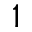Convert formula to latex. <formula><loc_0><loc_0><loc_500><loc_500>1</formula> 